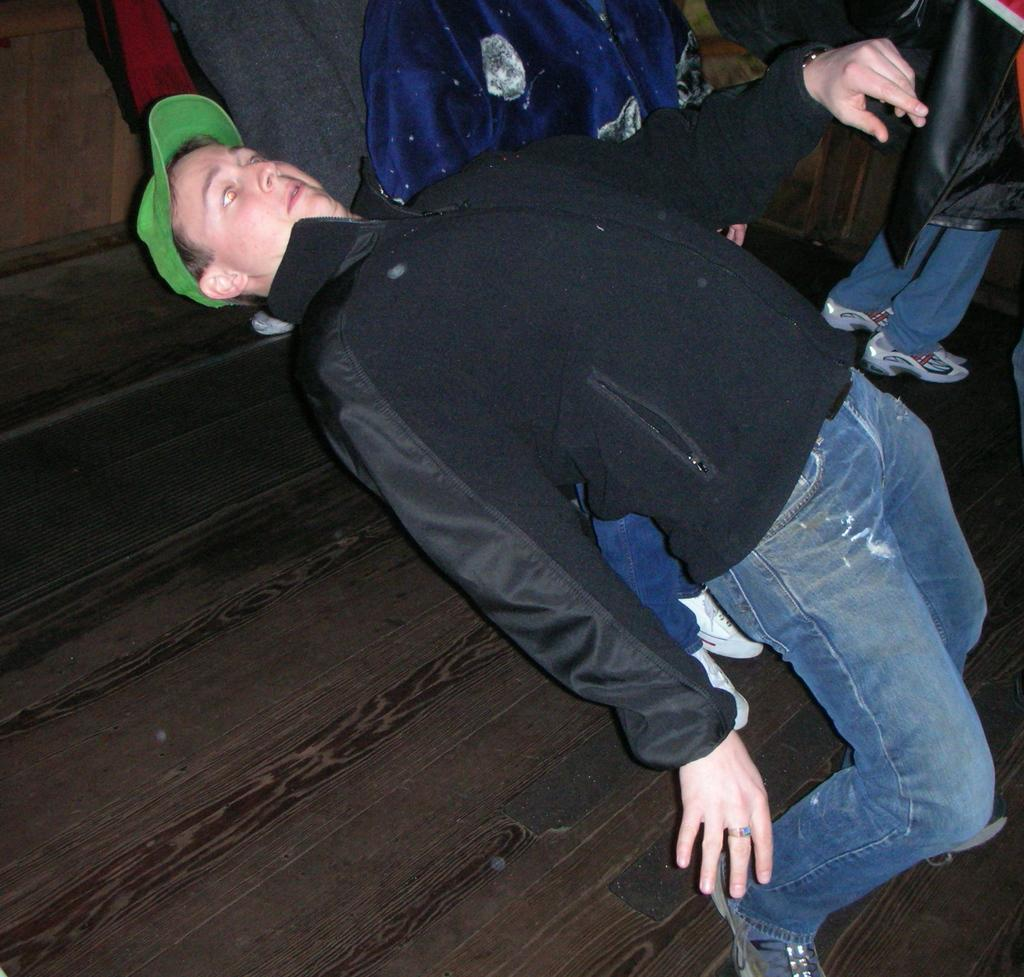How many people are in the image? There are people in the image. Can you describe the clothing of one of the people? One person is wearing a black and blue color dress. What color is the wall in the background of the image? The wall in the background is brown. What type of face is visible on the wall in the image? There is no face visible on the wall in the image; it is simply a brown wall. 